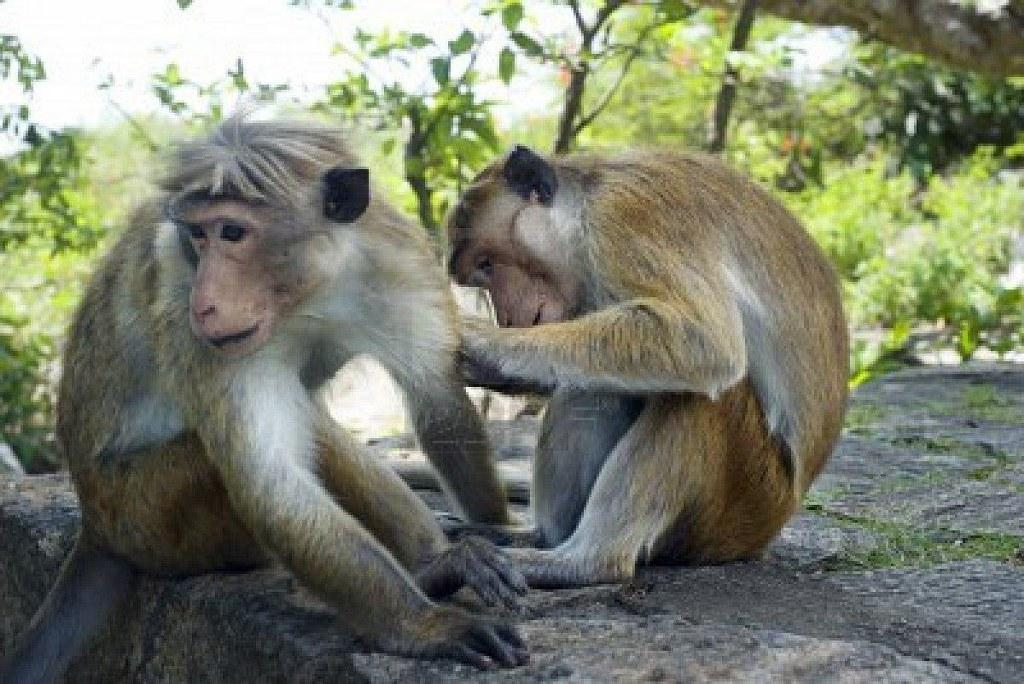How many monkeys are present in the image? There are two monkeys sitting in the image. What else can be seen in the image besides the monkeys? There is a rock and trees visible in the image. Can you describe the background of the image? The background of the image is slightly blurred. What type of coal is being used by the monkeys in the image? There is no coal present in the image; it features two monkeys sitting with a rock and trees in the background. Can you locate a map in the image? There is no map present in the image. 